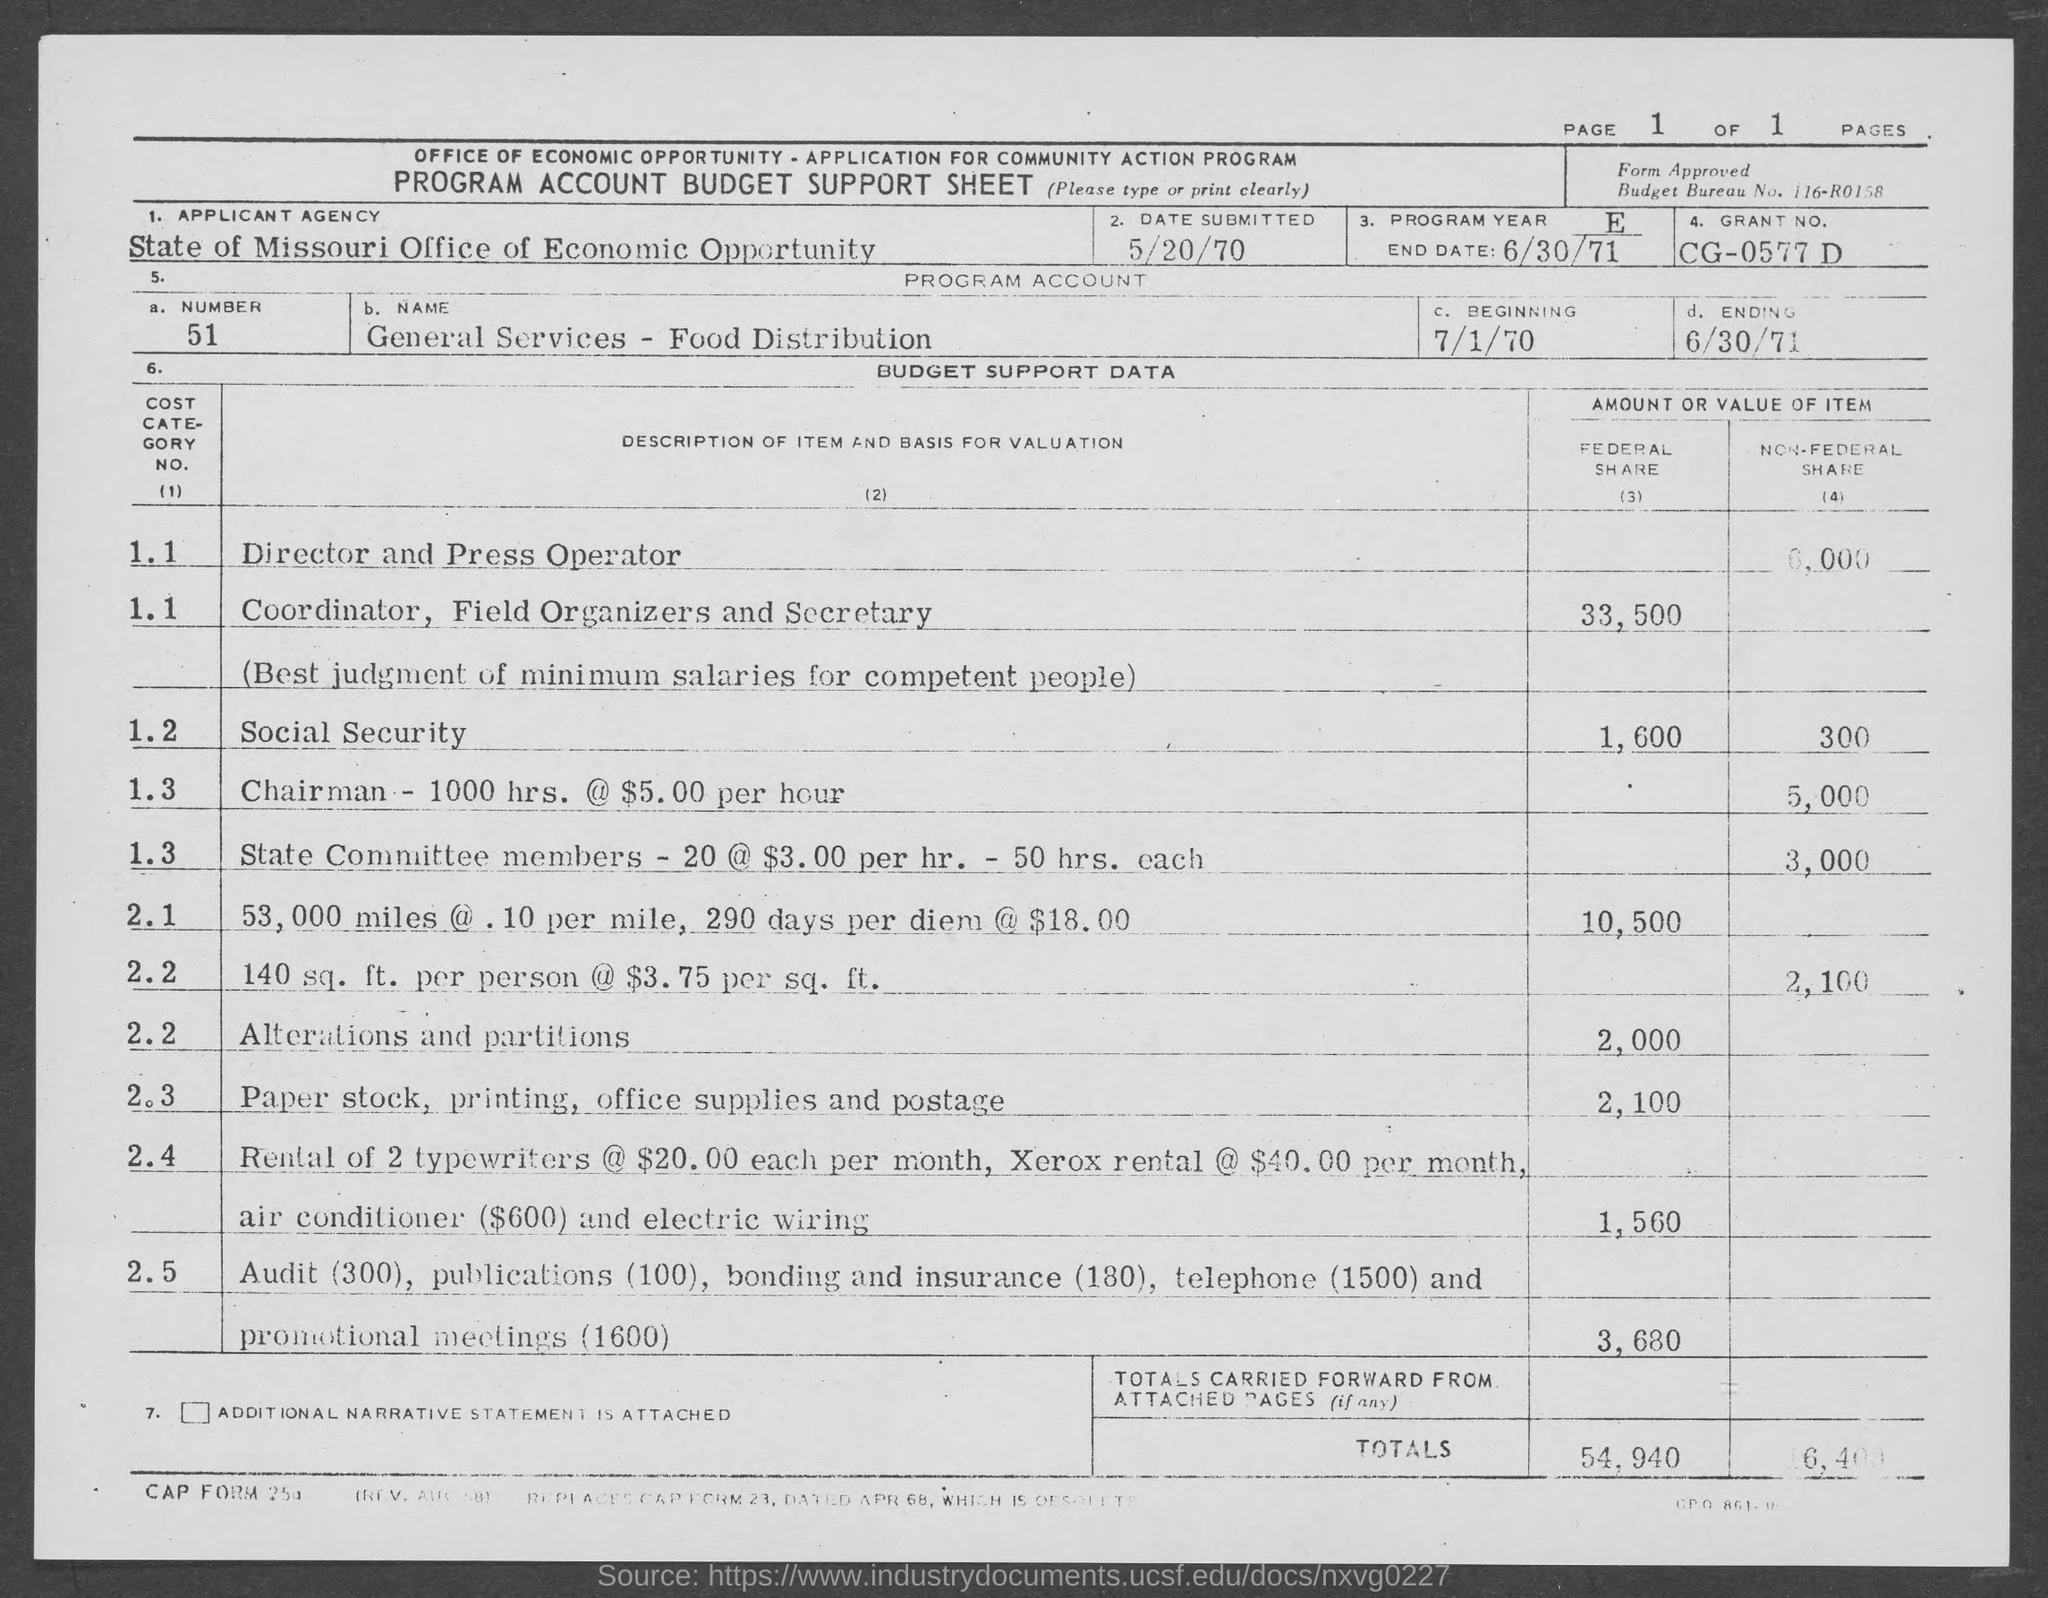What is the applicant agency ?
Give a very brief answer. State of missouri office of economic opportunity. What is the program account number ?
Your response must be concise. 51. When is the program account beginning ?
Offer a terse response. 7/1/70. When is the program account ending ?
Ensure brevity in your answer.  6/30/71. 